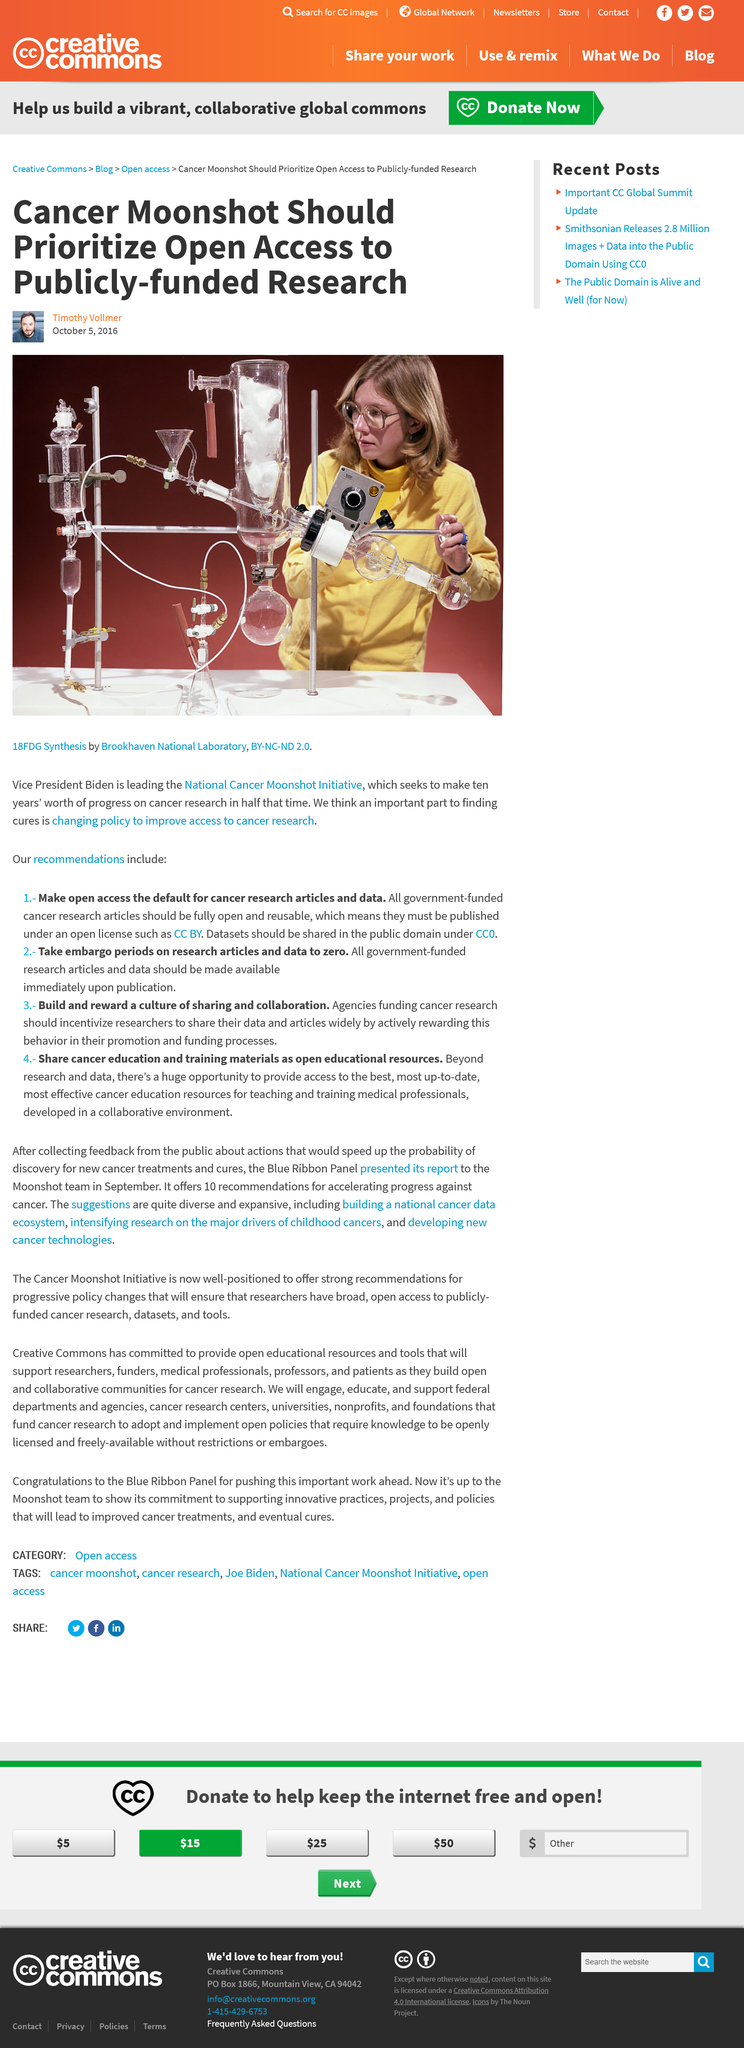Point out several critical features in this image. The main image is titled "18FDG Synthesis. The National Cancer Moonshot Initiative aims to achieve in five years the amount of progress that would typically take ten years. The National Cancer Moonshot Initiative is being led by Vice President Biden, who is leading the initiative to achieve a comprehensive and sustainable victory over cancer as a nation. 